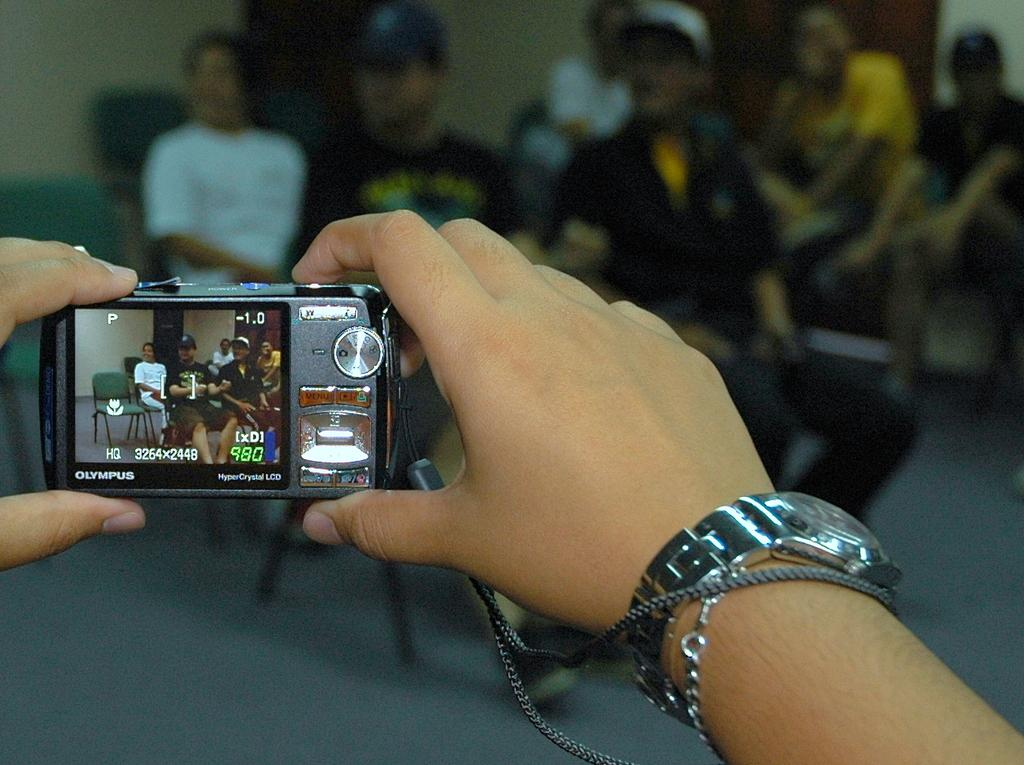What is the main subject of the image? The main subject of the image is a hand holding a camera. To whom does the hand belong? The hand belongs to a person. What can be seen in the background of the image? There are people sitting on chairs in the background of the image. Where is the nest located in the image? There is no nest present in the image. What type of stocking is being worn by the person holding the camera? The image does not show any stockings being worn by the person holding the camera. 